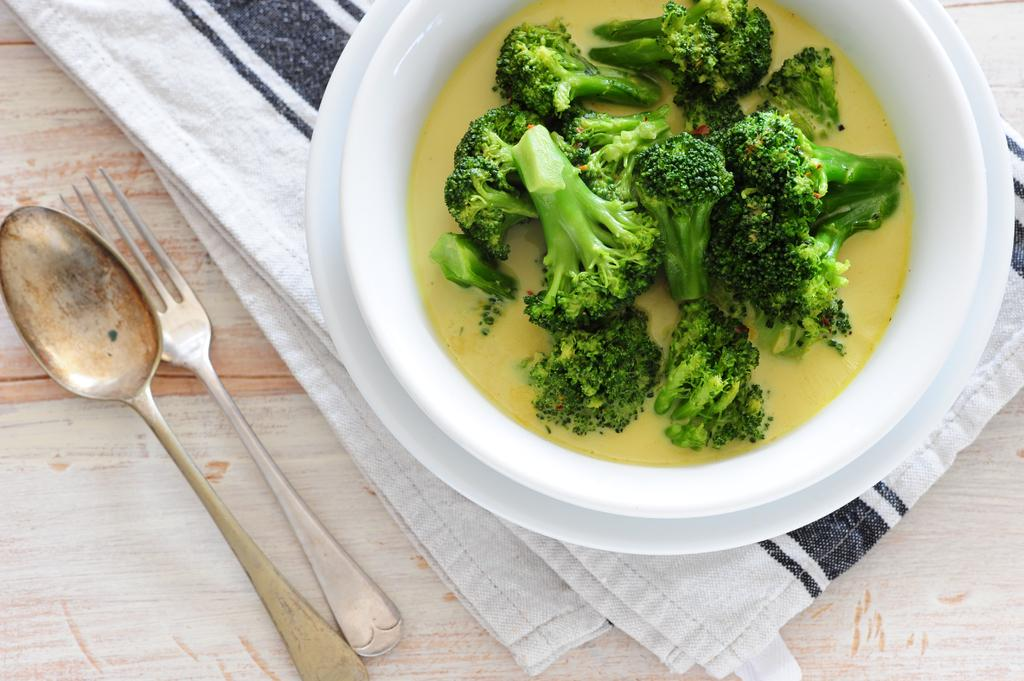What is in the bowl that is visible in the image? There is food in a bowl in the image. What utensils can be seen in the image? There are spoons visible in the image. What other items are present on the table in the image? There are clothes on the table in the image. What type of pancake is being served in the image? There is no pancake present in the image; it is a bowl of food with spoons and clothes on the table. In which direction are the clothes arranged on the table? The direction in which the clothes are arranged on the table cannot be determined from the image. Are there any stockings visible in the image? There is no mention of stockings in the provided facts, and therefore it cannot be determined if any are present in the image. 